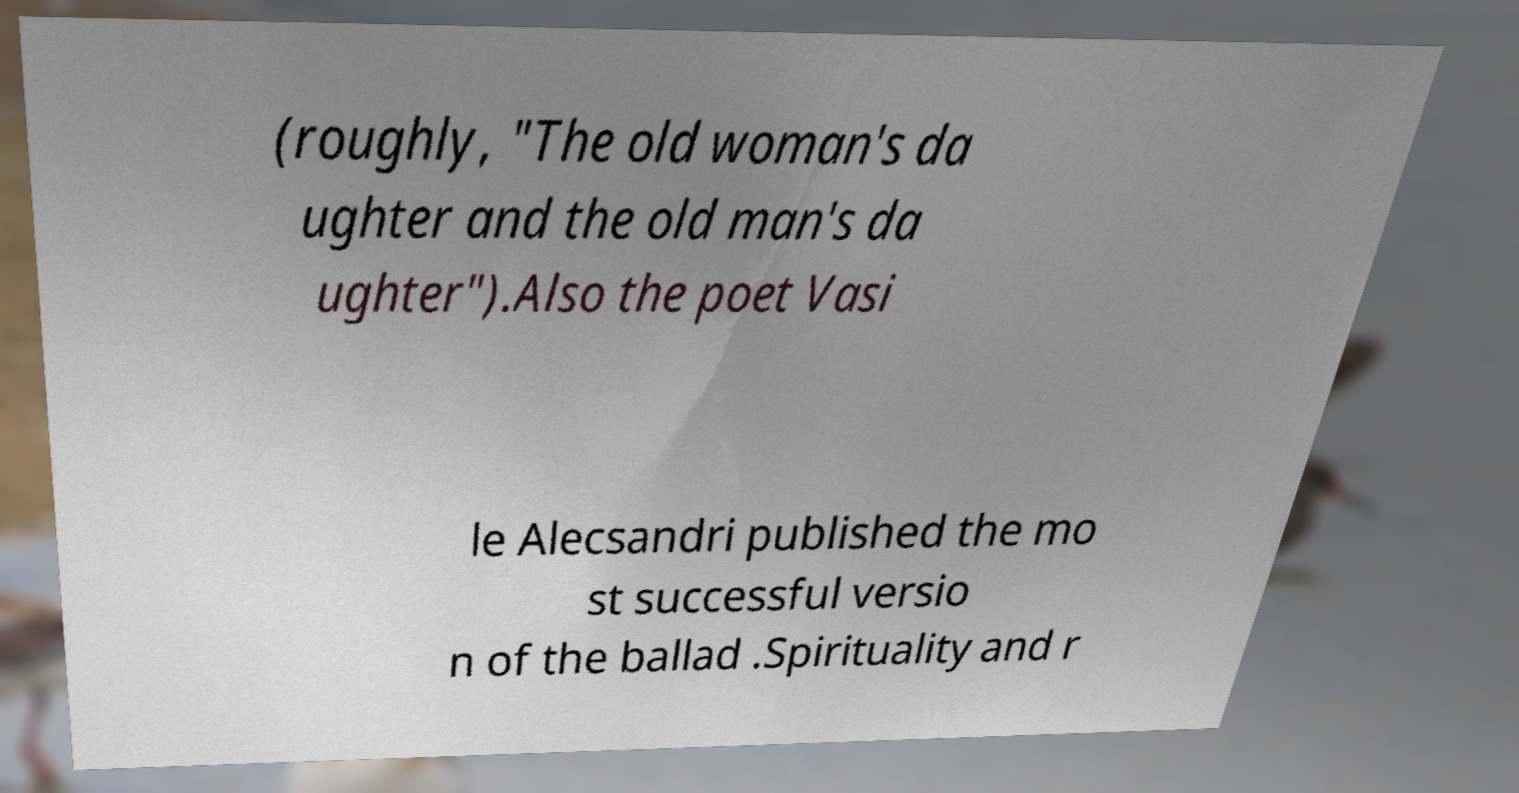Can you read and provide the text displayed in the image?This photo seems to have some interesting text. Can you extract and type it out for me? (roughly, "The old woman's da ughter and the old man's da ughter").Also the poet Vasi le Alecsandri published the mo st successful versio n of the ballad .Spirituality and r 